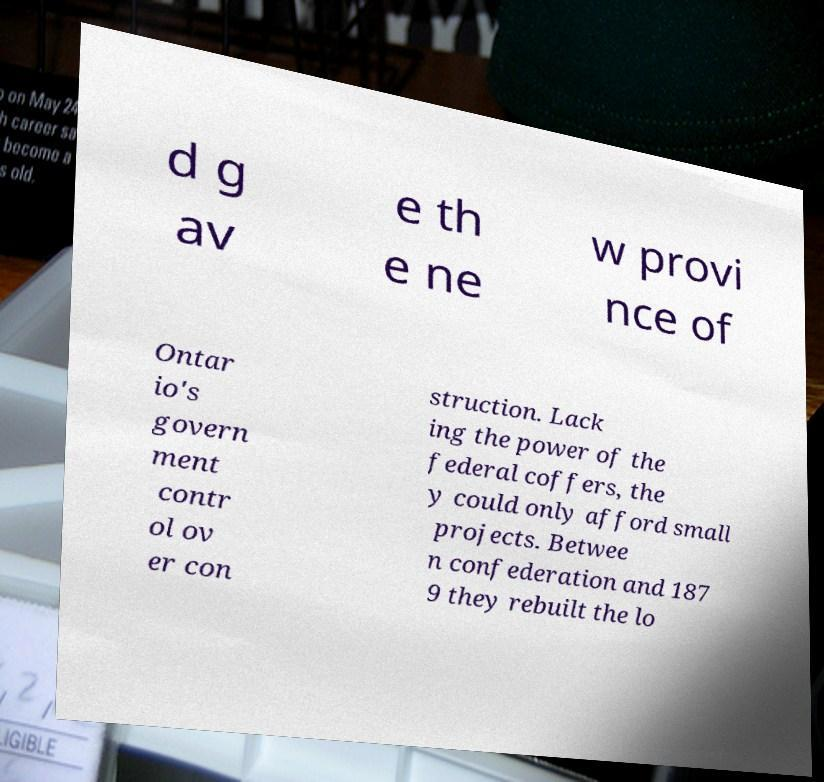There's text embedded in this image that I need extracted. Can you transcribe it verbatim? d g av e th e ne w provi nce of Ontar io's govern ment contr ol ov er con struction. Lack ing the power of the federal coffers, the y could only afford small projects. Betwee n confederation and 187 9 they rebuilt the lo 